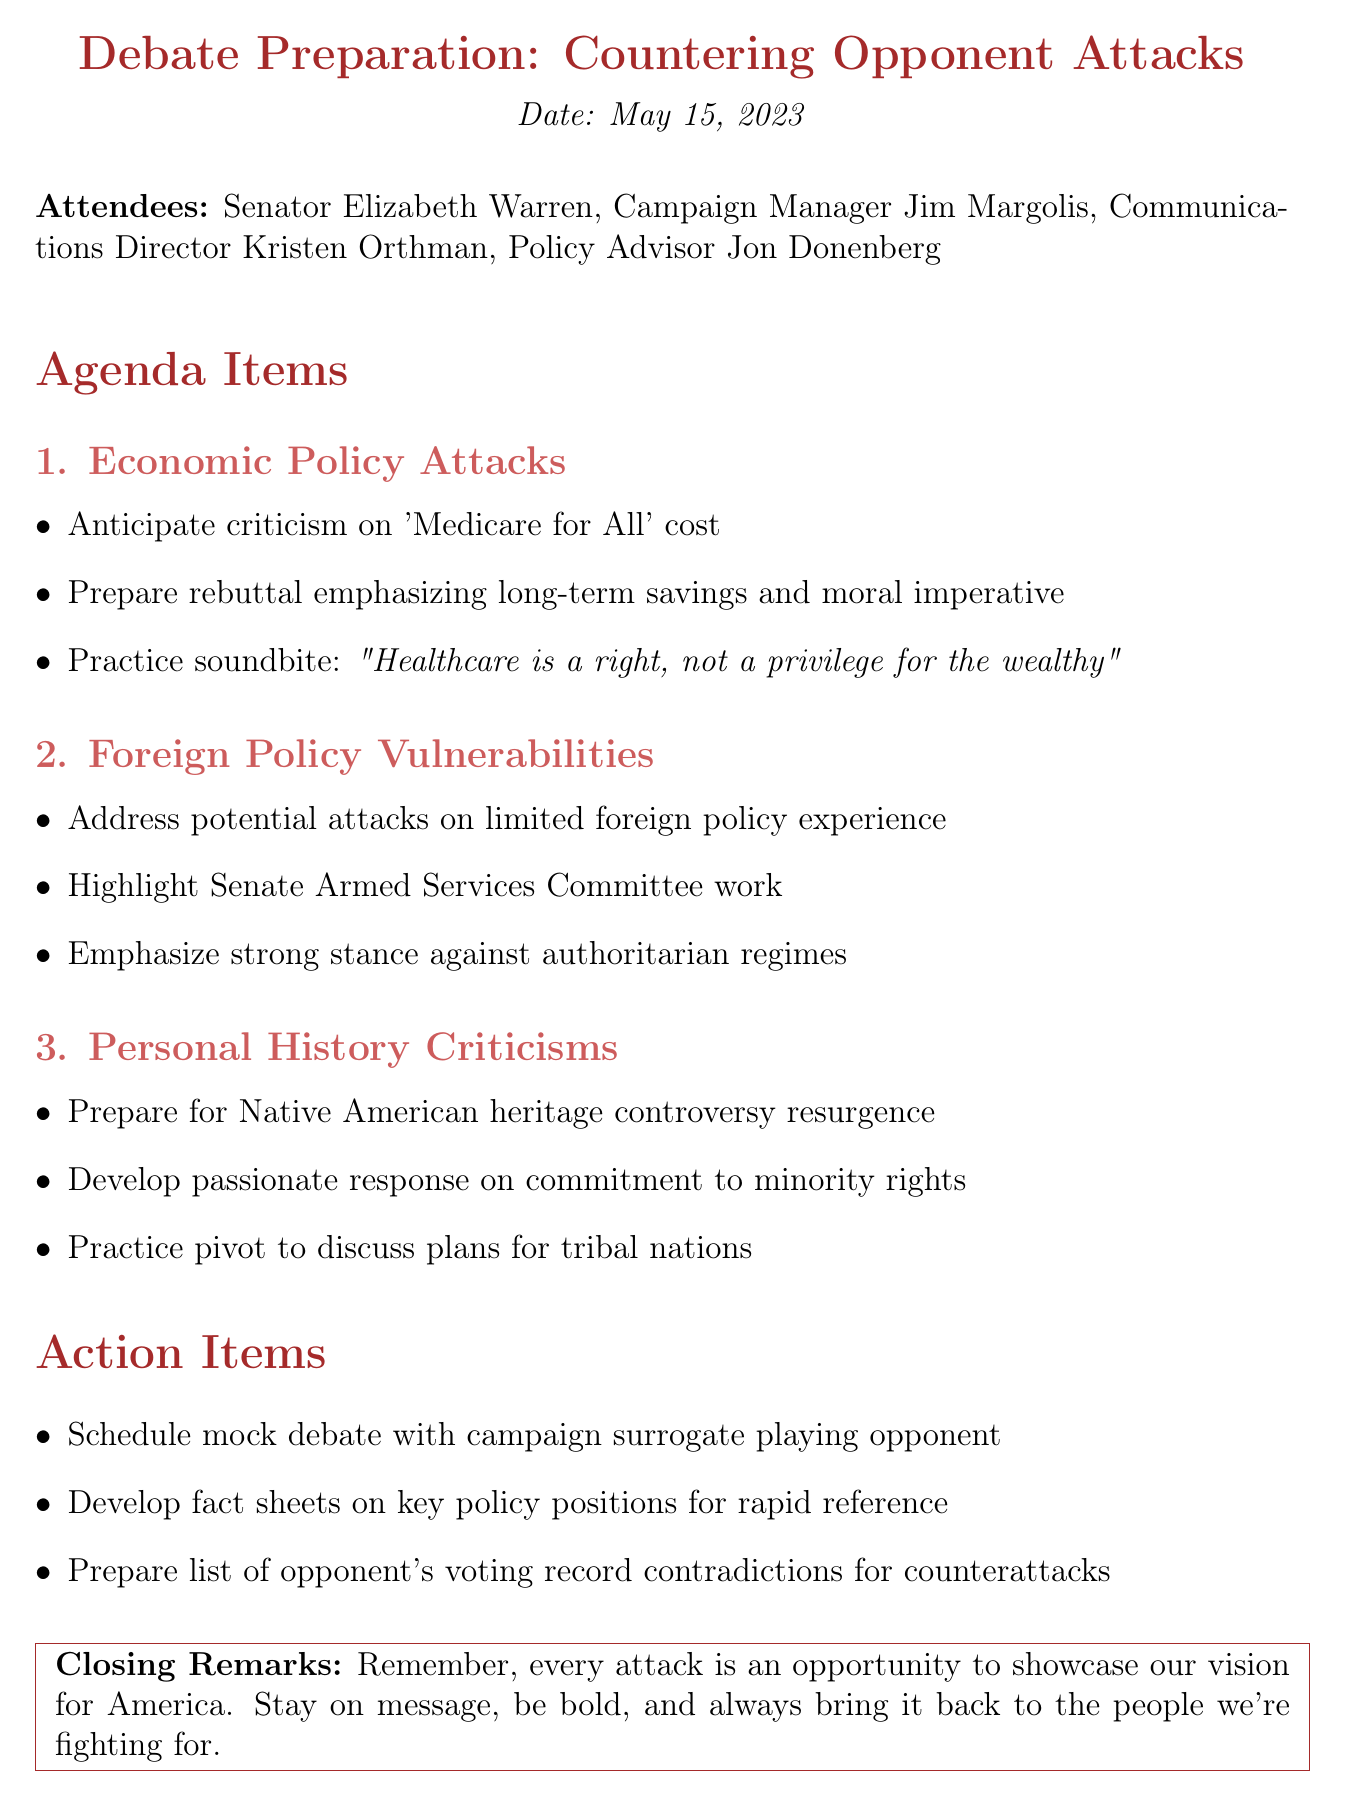What is the date of the meeting? The date of the meeting is explicitly mentioned at the start of the document.
Answer: May 15, 2023 Who is the Campaign Manager? The document lists attendees, including the role of each participant.
Answer: Jim Margolis What is the first agenda item discussed? The agenda items are numbered and titled in the document, with the first one clearly stated.
Answer: Economic Policy Attacks What is one prepared rebuttal for the economic policy attacks? The document specifies key points under each agenda item, including prepared rebuttals.
Answer: long-term savings and moral imperative Which committee's work is highlighted in relation to foreign policy? The document refers to the relevant committees under the foreign policy agenda item.
Answer: Senate Armed Services Committee What is the final action item listed in the meeting minutes? Action items are presented at the end of the document, and the last item is listed clearly.
Answer: Prepare list of opponent's voting record contradictions for counterattacks What is the quote practiced for the economic policy attacks? The document includes a specific soundbite intended for preparation against attacks.
Answer: "Healthcare is a right, not a privilege for the wealthy" Who is responsible for preparing fact sheets? The document mentions action items, indicating who is involved in specific tasks.
Answer: Not explicitly stated 